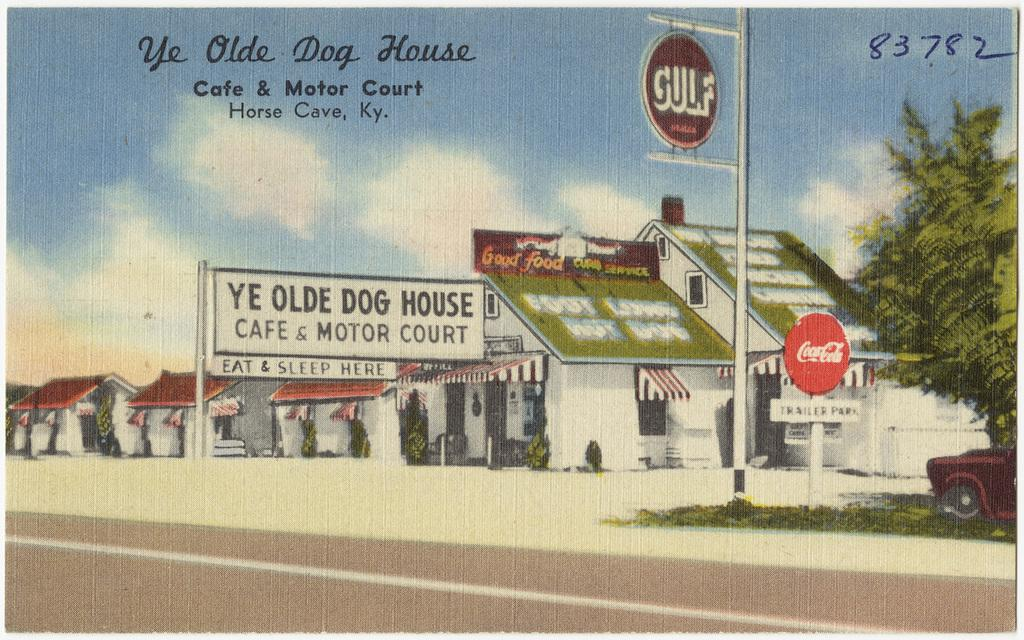Provide a one-sentence caption for the provided image. A picture that features the Ye Olde Dog House Cafe & Motor Court in Horse Cave, KY. 